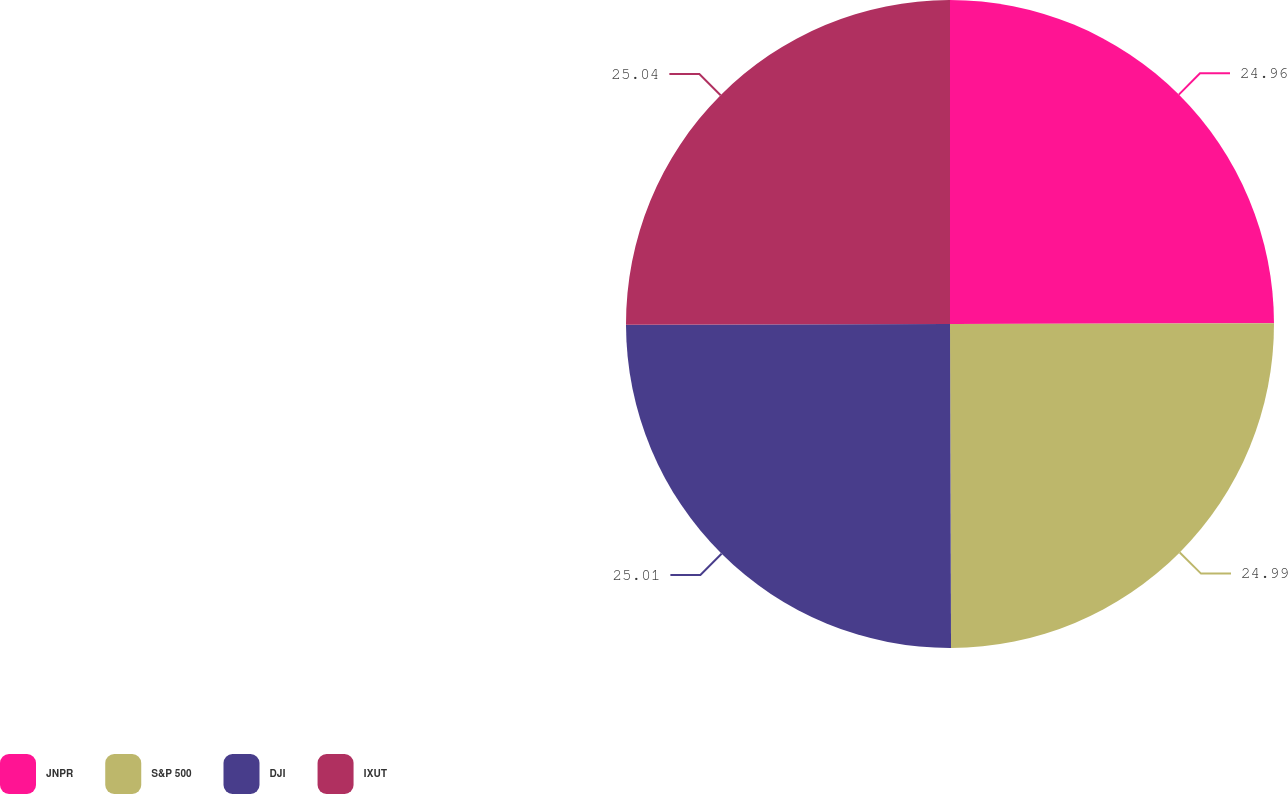Convert chart. <chart><loc_0><loc_0><loc_500><loc_500><pie_chart><fcel>JNPR<fcel>S&P 500<fcel>DJI<fcel>IXUT<nl><fcel>24.96%<fcel>24.99%<fcel>25.01%<fcel>25.04%<nl></chart> 